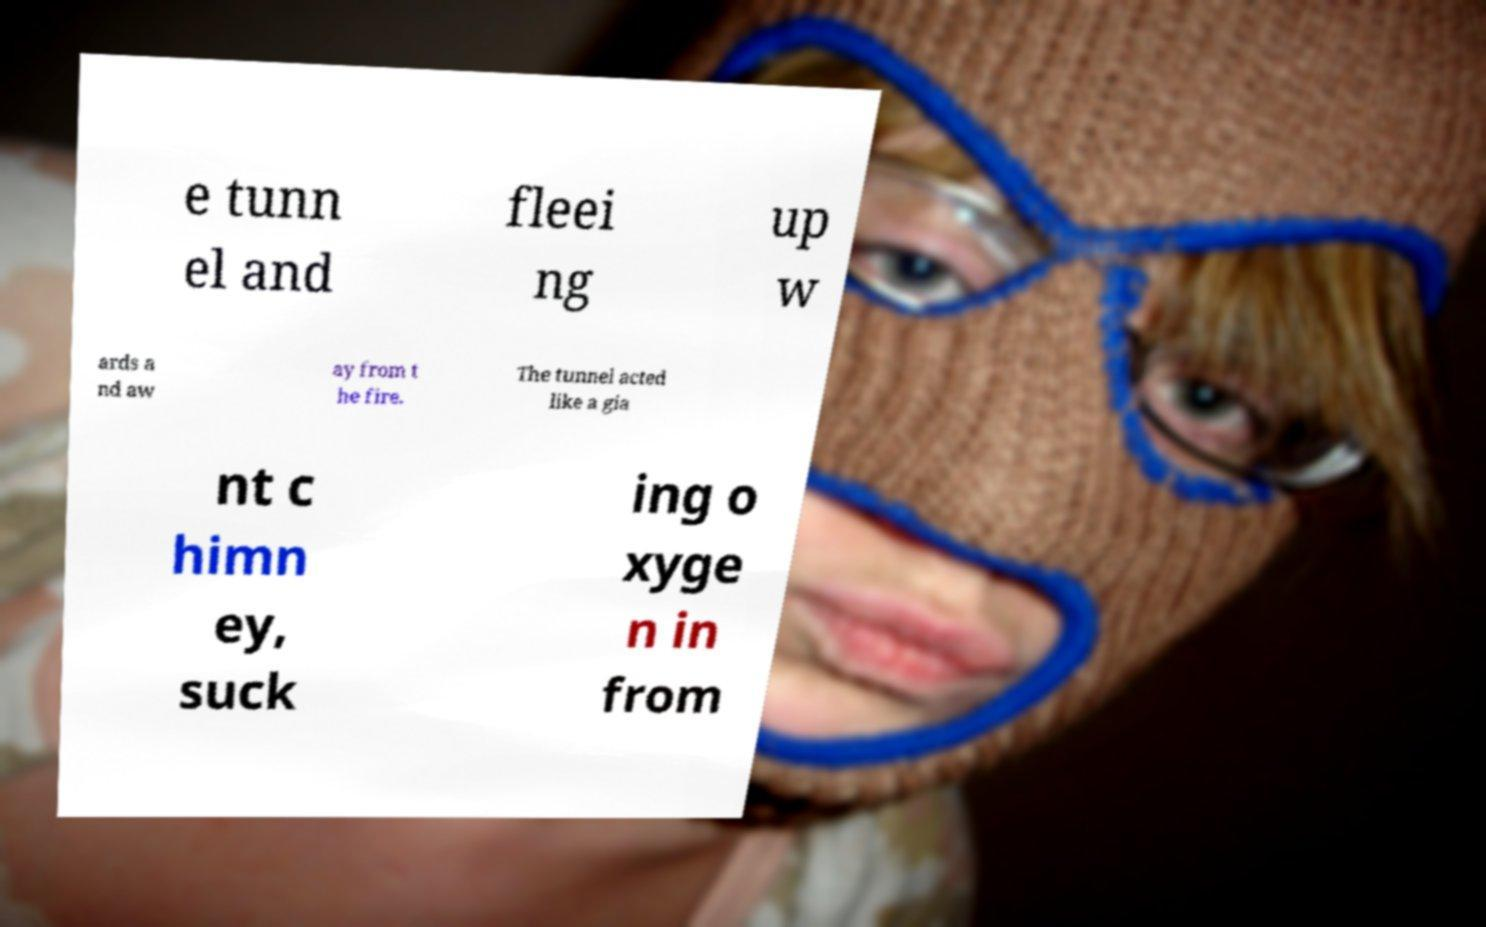Could you assist in decoding the text presented in this image and type it out clearly? e tunn el and fleei ng up w ards a nd aw ay from t he fire. The tunnel acted like a gia nt c himn ey, suck ing o xyge n in from 